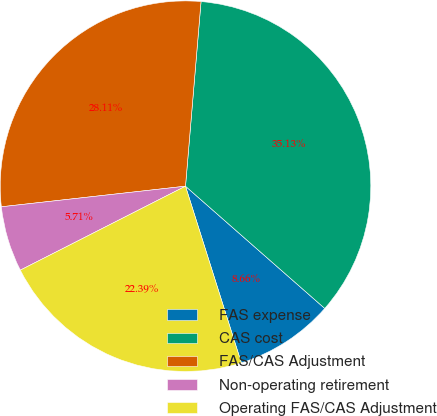Convert chart. <chart><loc_0><loc_0><loc_500><loc_500><pie_chart><fcel>FAS expense<fcel>CAS cost<fcel>FAS/CAS Adjustment<fcel>Non-operating retirement<fcel>Operating FAS/CAS Adjustment<nl><fcel>8.66%<fcel>35.13%<fcel>28.11%<fcel>5.71%<fcel>22.39%<nl></chart> 